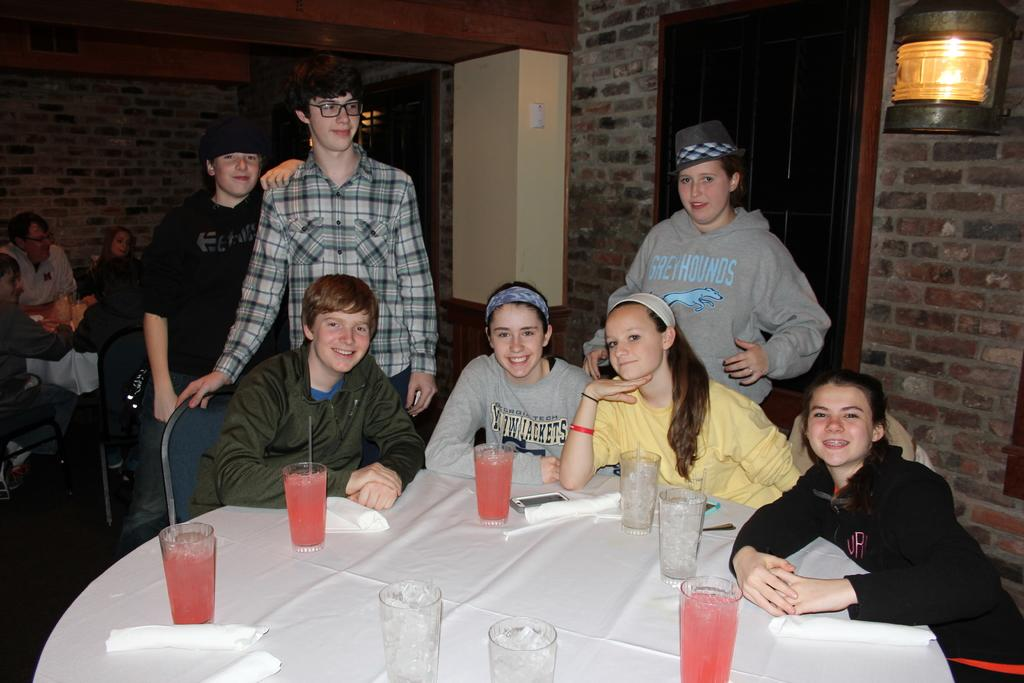What are the people in the image doing? The people in the image are sitting on chairs. Are there any other people visible in the image? Yes, there are people standing in the background of the image. What can be seen on the table in the image? There are juice glasses on a table in the image. What degree do the sheep in the image have? There are no sheep present in the image. What type of pencil is being used by the people in the image? There is no pencil visible in the image. 